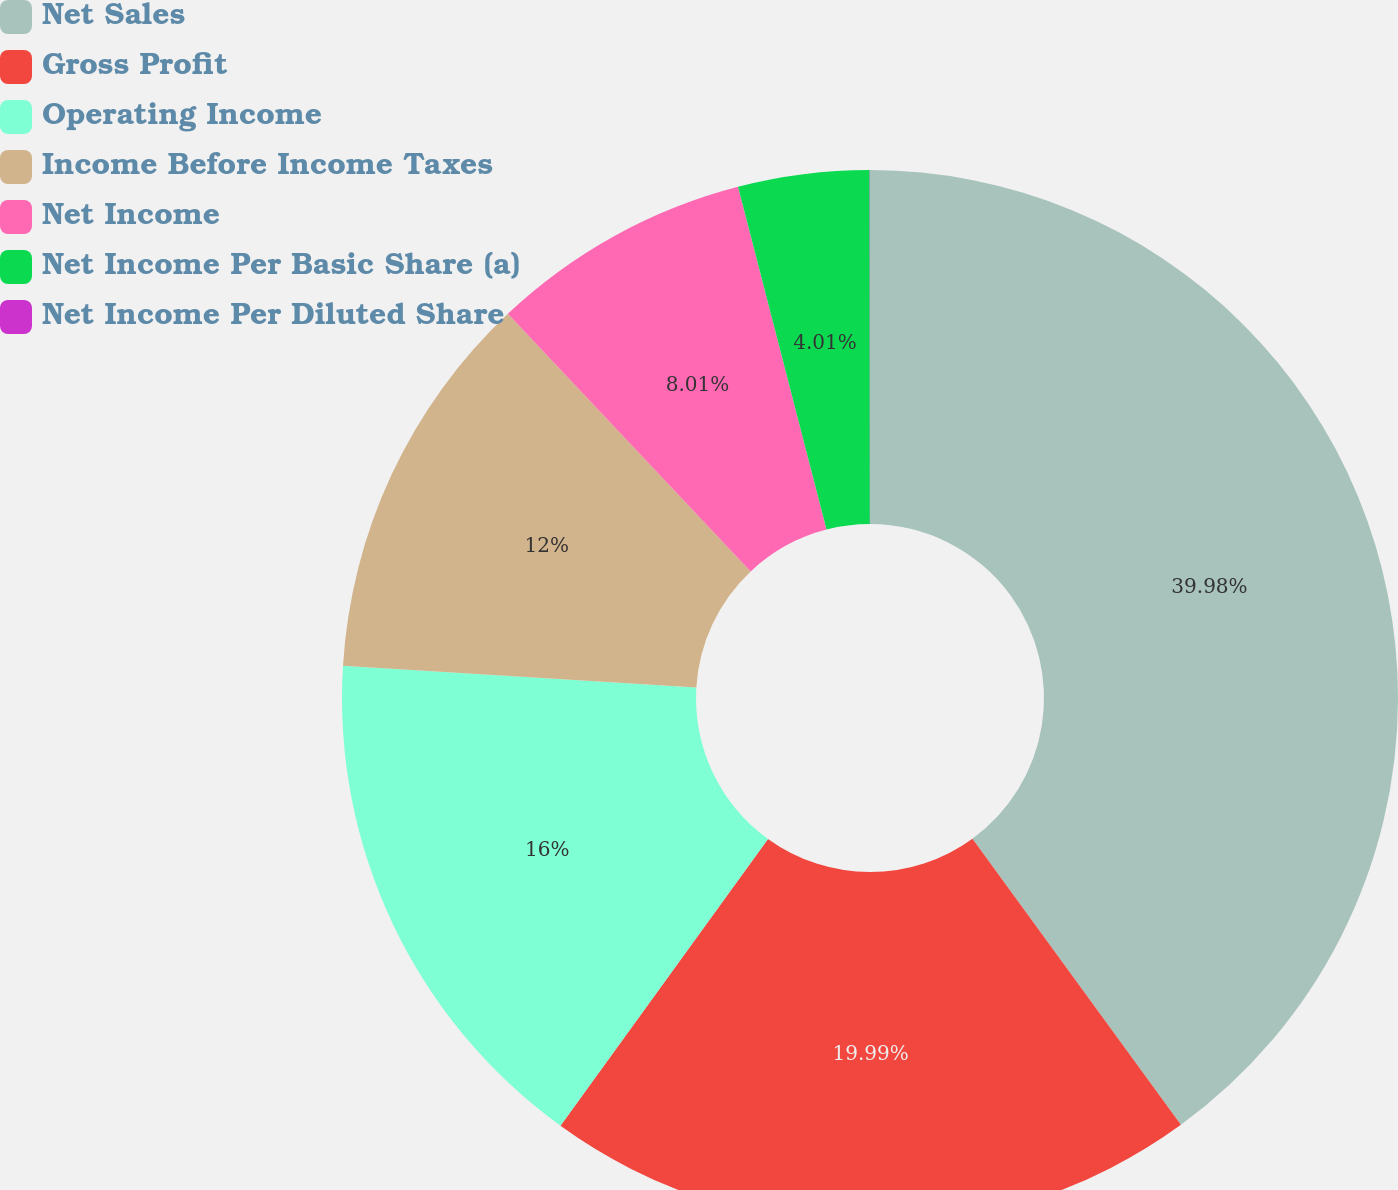Convert chart. <chart><loc_0><loc_0><loc_500><loc_500><pie_chart><fcel>Net Sales<fcel>Gross Profit<fcel>Operating Income<fcel>Income Before Income Taxes<fcel>Net Income<fcel>Net Income Per Basic Share (a)<fcel>Net Income Per Diluted Share<nl><fcel>39.98%<fcel>19.99%<fcel>16.0%<fcel>12.0%<fcel>8.01%<fcel>4.01%<fcel>0.01%<nl></chart> 